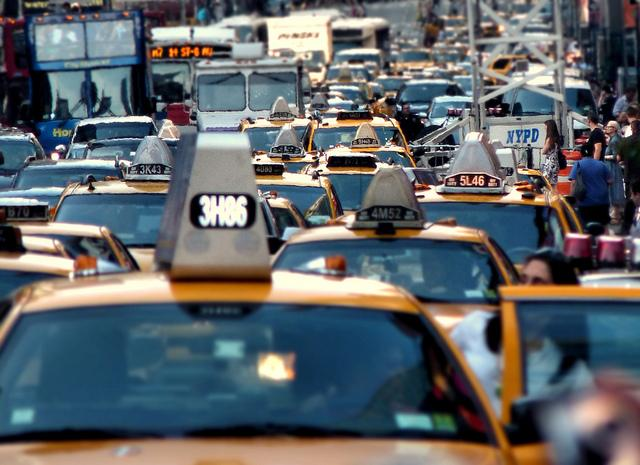What is happening on the road?

Choices:
A) protest
B) parade
C) traffic jam
D) car accident traffic jam 